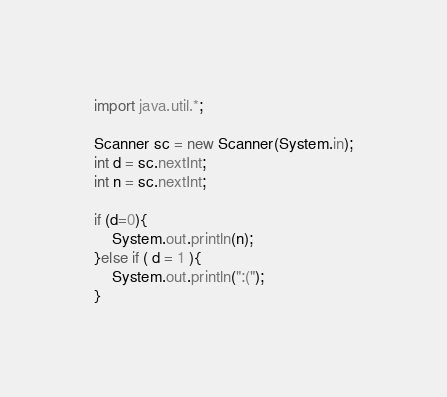<code> <loc_0><loc_0><loc_500><loc_500><_Java_>import java.util.*;

Scanner sc = new Scanner(System.in);
int d = sc.nextInt;
int n = sc.nextInt;

if (d=0){
	System.out.println(n);
}else if ( d = 1 ){
	System.out.println(":(");
}</code> 